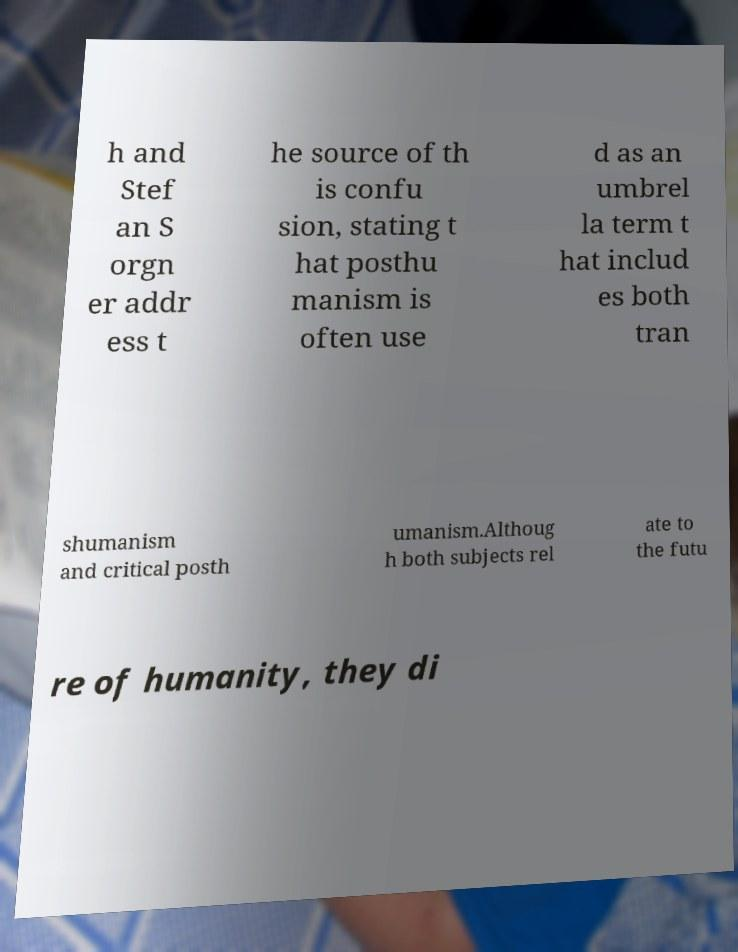Can you read and provide the text displayed in the image?This photo seems to have some interesting text. Can you extract and type it out for me? h and Stef an S orgn er addr ess t he source of th is confu sion, stating t hat posthu manism is often use d as an umbrel la term t hat includ es both tran shumanism and critical posth umanism.Althoug h both subjects rel ate to the futu re of humanity, they di 